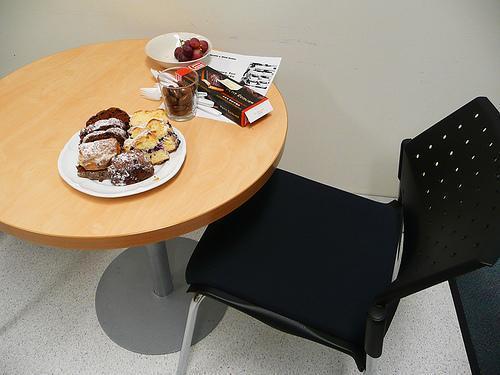How many table can you see?
Give a very brief answer. 1. 